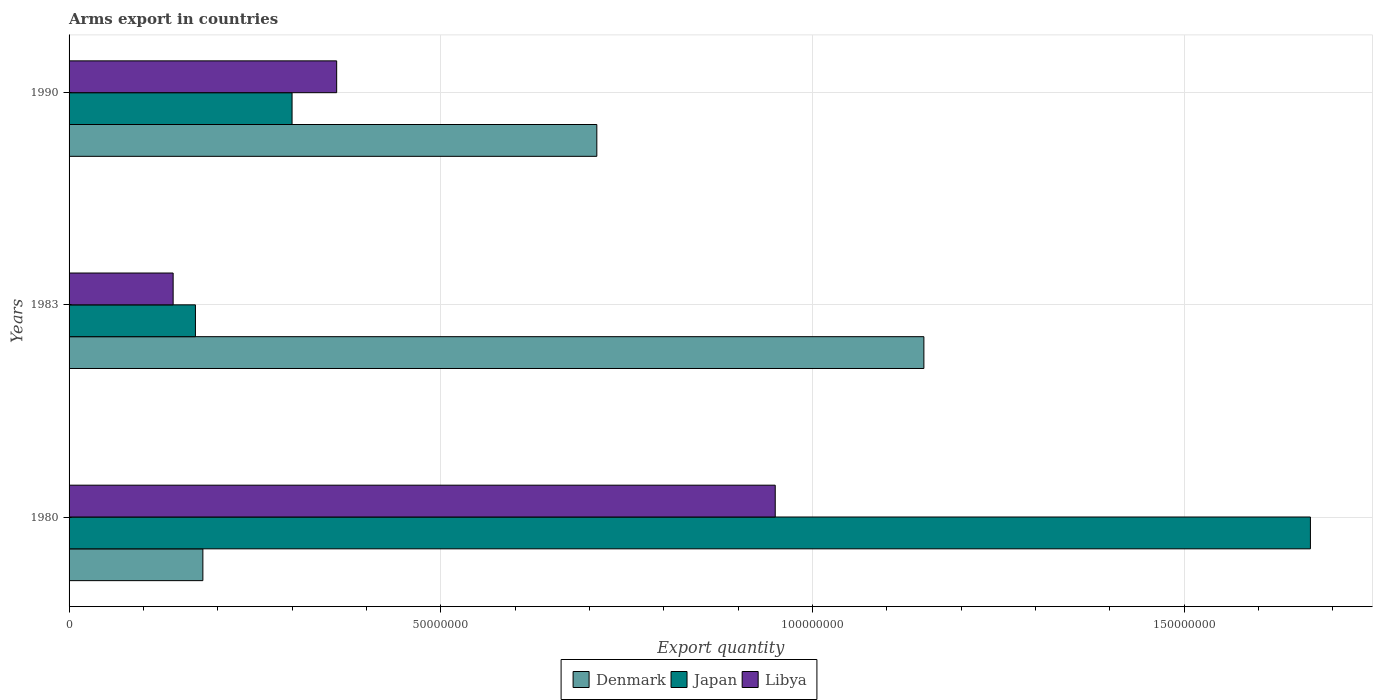Are the number of bars per tick equal to the number of legend labels?
Ensure brevity in your answer.  Yes. Are the number of bars on each tick of the Y-axis equal?
Offer a terse response. Yes. How many bars are there on the 2nd tick from the top?
Provide a short and direct response. 3. What is the label of the 1st group of bars from the top?
Ensure brevity in your answer.  1990. In how many cases, is the number of bars for a given year not equal to the number of legend labels?
Give a very brief answer. 0. What is the total arms export in Denmark in 1980?
Your answer should be compact. 1.80e+07. Across all years, what is the maximum total arms export in Japan?
Offer a terse response. 1.67e+08. Across all years, what is the minimum total arms export in Japan?
Your answer should be very brief. 1.70e+07. In which year was the total arms export in Denmark minimum?
Offer a terse response. 1980. What is the total total arms export in Denmark in the graph?
Give a very brief answer. 2.04e+08. What is the difference between the total arms export in Libya in 1980 and that in 1983?
Provide a short and direct response. 8.10e+07. What is the difference between the total arms export in Libya in 1980 and the total arms export in Denmark in 1983?
Provide a succinct answer. -2.00e+07. What is the average total arms export in Libya per year?
Keep it short and to the point. 4.83e+07. In the year 1983, what is the difference between the total arms export in Denmark and total arms export in Japan?
Make the answer very short. 9.80e+07. In how many years, is the total arms export in Japan greater than 80000000 ?
Provide a succinct answer. 1. What is the ratio of the total arms export in Denmark in 1980 to that in 1983?
Your answer should be very brief. 0.16. Is the total arms export in Japan in 1980 less than that in 1983?
Provide a succinct answer. No. What is the difference between the highest and the second highest total arms export in Japan?
Ensure brevity in your answer.  1.37e+08. What is the difference between the highest and the lowest total arms export in Japan?
Offer a terse response. 1.50e+08. In how many years, is the total arms export in Libya greater than the average total arms export in Libya taken over all years?
Keep it short and to the point. 1. What does the 3rd bar from the top in 1983 represents?
Ensure brevity in your answer.  Denmark. Does the graph contain any zero values?
Provide a succinct answer. No. Does the graph contain grids?
Provide a succinct answer. Yes. Where does the legend appear in the graph?
Ensure brevity in your answer.  Bottom center. What is the title of the graph?
Offer a terse response. Arms export in countries. What is the label or title of the X-axis?
Offer a terse response. Export quantity. What is the Export quantity in Denmark in 1980?
Keep it short and to the point. 1.80e+07. What is the Export quantity of Japan in 1980?
Offer a terse response. 1.67e+08. What is the Export quantity of Libya in 1980?
Your answer should be compact. 9.50e+07. What is the Export quantity of Denmark in 1983?
Offer a terse response. 1.15e+08. What is the Export quantity in Japan in 1983?
Ensure brevity in your answer.  1.70e+07. What is the Export quantity in Libya in 1983?
Your answer should be very brief. 1.40e+07. What is the Export quantity in Denmark in 1990?
Provide a succinct answer. 7.10e+07. What is the Export quantity of Japan in 1990?
Your response must be concise. 3.00e+07. What is the Export quantity of Libya in 1990?
Your answer should be very brief. 3.60e+07. Across all years, what is the maximum Export quantity of Denmark?
Keep it short and to the point. 1.15e+08. Across all years, what is the maximum Export quantity in Japan?
Your response must be concise. 1.67e+08. Across all years, what is the maximum Export quantity of Libya?
Provide a short and direct response. 9.50e+07. Across all years, what is the minimum Export quantity of Denmark?
Keep it short and to the point. 1.80e+07. Across all years, what is the minimum Export quantity in Japan?
Offer a very short reply. 1.70e+07. Across all years, what is the minimum Export quantity in Libya?
Provide a short and direct response. 1.40e+07. What is the total Export quantity in Denmark in the graph?
Your answer should be compact. 2.04e+08. What is the total Export quantity of Japan in the graph?
Keep it short and to the point. 2.14e+08. What is the total Export quantity of Libya in the graph?
Your response must be concise. 1.45e+08. What is the difference between the Export quantity of Denmark in 1980 and that in 1983?
Offer a very short reply. -9.70e+07. What is the difference between the Export quantity in Japan in 1980 and that in 1983?
Ensure brevity in your answer.  1.50e+08. What is the difference between the Export quantity of Libya in 1980 and that in 1983?
Offer a very short reply. 8.10e+07. What is the difference between the Export quantity in Denmark in 1980 and that in 1990?
Your response must be concise. -5.30e+07. What is the difference between the Export quantity in Japan in 1980 and that in 1990?
Your response must be concise. 1.37e+08. What is the difference between the Export quantity of Libya in 1980 and that in 1990?
Provide a short and direct response. 5.90e+07. What is the difference between the Export quantity in Denmark in 1983 and that in 1990?
Give a very brief answer. 4.40e+07. What is the difference between the Export quantity of Japan in 1983 and that in 1990?
Offer a very short reply. -1.30e+07. What is the difference between the Export quantity in Libya in 1983 and that in 1990?
Offer a very short reply. -2.20e+07. What is the difference between the Export quantity in Denmark in 1980 and the Export quantity in Japan in 1983?
Offer a terse response. 1.00e+06. What is the difference between the Export quantity of Denmark in 1980 and the Export quantity of Libya in 1983?
Your answer should be very brief. 4.00e+06. What is the difference between the Export quantity of Japan in 1980 and the Export quantity of Libya in 1983?
Offer a very short reply. 1.53e+08. What is the difference between the Export quantity of Denmark in 1980 and the Export quantity of Japan in 1990?
Provide a short and direct response. -1.20e+07. What is the difference between the Export quantity in Denmark in 1980 and the Export quantity in Libya in 1990?
Make the answer very short. -1.80e+07. What is the difference between the Export quantity in Japan in 1980 and the Export quantity in Libya in 1990?
Offer a terse response. 1.31e+08. What is the difference between the Export quantity of Denmark in 1983 and the Export quantity of Japan in 1990?
Your answer should be very brief. 8.50e+07. What is the difference between the Export quantity of Denmark in 1983 and the Export quantity of Libya in 1990?
Your response must be concise. 7.90e+07. What is the difference between the Export quantity of Japan in 1983 and the Export quantity of Libya in 1990?
Your answer should be compact. -1.90e+07. What is the average Export quantity of Denmark per year?
Provide a short and direct response. 6.80e+07. What is the average Export quantity of Japan per year?
Your answer should be compact. 7.13e+07. What is the average Export quantity in Libya per year?
Make the answer very short. 4.83e+07. In the year 1980, what is the difference between the Export quantity of Denmark and Export quantity of Japan?
Offer a terse response. -1.49e+08. In the year 1980, what is the difference between the Export quantity of Denmark and Export quantity of Libya?
Offer a terse response. -7.70e+07. In the year 1980, what is the difference between the Export quantity in Japan and Export quantity in Libya?
Your answer should be very brief. 7.20e+07. In the year 1983, what is the difference between the Export quantity of Denmark and Export quantity of Japan?
Offer a very short reply. 9.80e+07. In the year 1983, what is the difference between the Export quantity in Denmark and Export quantity in Libya?
Provide a succinct answer. 1.01e+08. In the year 1990, what is the difference between the Export quantity in Denmark and Export quantity in Japan?
Provide a short and direct response. 4.10e+07. In the year 1990, what is the difference between the Export quantity in Denmark and Export quantity in Libya?
Your response must be concise. 3.50e+07. In the year 1990, what is the difference between the Export quantity of Japan and Export quantity of Libya?
Your response must be concise. -6.00e+06. What is the ratio of the Export quantity of Denmark in 1980 to that in 1983?
Provide a short and direct response. 0.16. What is the ratio of the Export quantity of Japan in 1980 to that in 1983?
Your response must be concise. 9.82. What is the ratio of the Export quantity of Libya in 1980 to that in 1983?
Provide a succinct answer. 6.79. What is the ratio of the Export quantity of Denmark in 1980 to that in 1990?
Offer a terse response. 0.25. What is the ratio of the Export quantity in Japan in 1980 to that in 1990?
Your answer should be compact. 5.57. What is the ratio of the Export quantity of Libya in 1980 to that in 1990?
Keep it short and to the point. 2.64. What is the ratio of the Export quantity in Denmark in 1983 to that in 1990?
Provide a succinct answer. 1.62. What is the ratio of the Export quantity in Japan in 1983 to that in 1990?
Offer a very short reply. 0.57. What is the ratio of the Export quantity of Libya in 1983 to that in 1990?
Your answer should be compact. 0.39. What is the difference between the highest and the second highest Export quantity of Denmark?
Offer a terse response. 4.40e+07. What is the difference between the highest and the second highest Export quantity of Japan?
Offer a terse response. 1.37e+08. What is the difference between the highest and the second highest Export quantity in Libya?
Keep it short and to the point. 5.90e+07. What is the difference between the highest and the lowest Export quantity in Denmark?
Offer a terse response. 9.70e+07. What is the difference between the highest and the lowest Export quantity of Japan?
Your answer should be very brief. 1.50e+08. What is the difference between the highest and the lowest Export quantity in Libya?
Offer a terse response. 8.10e+07. 